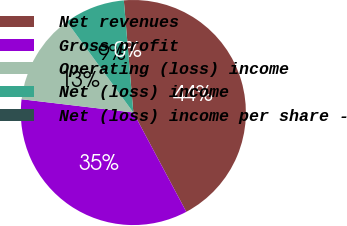<chart> <loc_0><loc_0><loc_500><loc_500><pie_chart><fcel>Net revenues<fcel>Gross profit<fcel>Operating (loss) income<fcel>Net (loss) income<fcel>Net (loss) income per share -<nl><fcel>43.55%<fcel>34.68%<fcel>13.06%<fcel>8.71%<fcel>0.0%<nl></chart> 